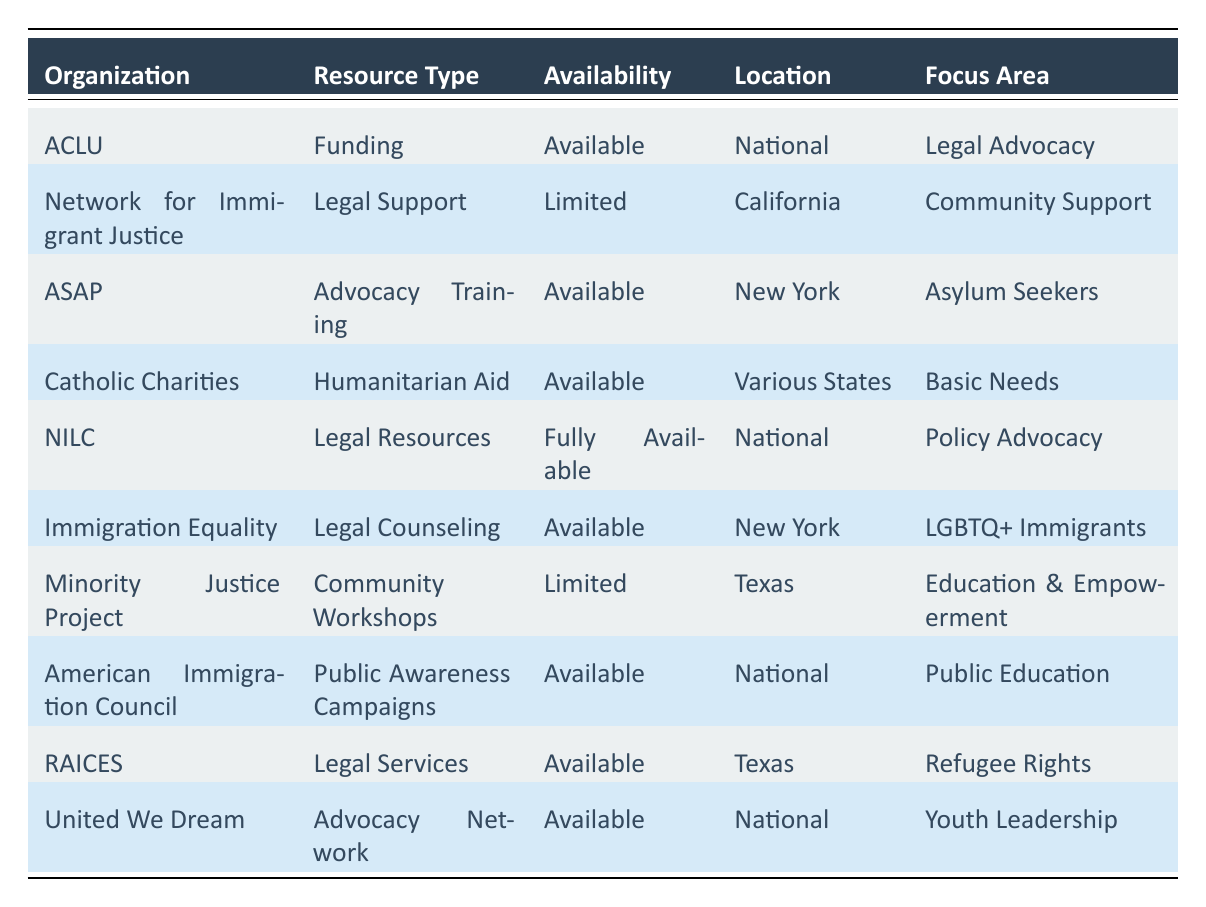What types of resources are available from the American Civil Liberties Union? The table shows the resource type associated with each organization. For the American Civil Liberties Union, the resource type listed is "Funding," which is categorized under "Available."
Answer: Funding Which organization provides legal counseling for LGBTQ+ immigrants and where is it located? According to the table, "Immigration Equality" provides "Legal Counseling" for LGBTQ+ immigrants, and it is located in "New York."
Answer: Immigration Equality, New York Is there any organization listed that offers fully available legal resources? The table indicates that the "National Immigration Law Center" offers "Legal Resources" which are categorized as "Fully Available."
Answer: Yes How many organizations in Texas have limited availability of resources? The table lists "Minority Justice Project," which offers "Community Workshops" with "Limited" availability, and this is the only organization for Texas with limited resources, so there is one.
Answer: 1 Which focus area has the most organizations providing resources, and how many organizations are there? The focus areas are unique to each organization or grouped; "Legal Advocacy," "Community Support," "Asylum Seekers," "Basic Needs," "Policy Advocacy," "LGBTQ+ Immigrants," "Education & Empowerment," "Refugee Rights," and "Youth Leadership" are listed. In total, there are 10 organizations with various focus areas. The area with the most resources is "Legal Advocacy" with 1 organization.
Answer: Legal Advocacy, 1 Can you find an organization that offers advocacy training, and what is its level of availability? From the table, the "Asylum Seeker Advocacy Project (ASAP)" offers "Advocacy Training," which is marked as "Available."
Answer: Available Are there any organizations that provide resources across multiple states? The "Catholic Charities" organization provides "Humanitarian Aid," which is available across "Various States" as listed in the table.
Answer: Yes How many organizations are categorized under Public Education, and what is their resource type? The table shows that the "American Immigration Council" is involved in "Public Education" and provides "Public Awareness Campaigns," so there is one organization under this category.
Answer: 1, Public Awareness Campaigns What is the location of the organization providing legal services for refugees, and what is its availability status? The "Refugee and Immigrant Center for Education and Legal Services (RAICES)" provides "Legal Services" in Texas, and its availability is listed as "Available."
Answer: Texas, Available 